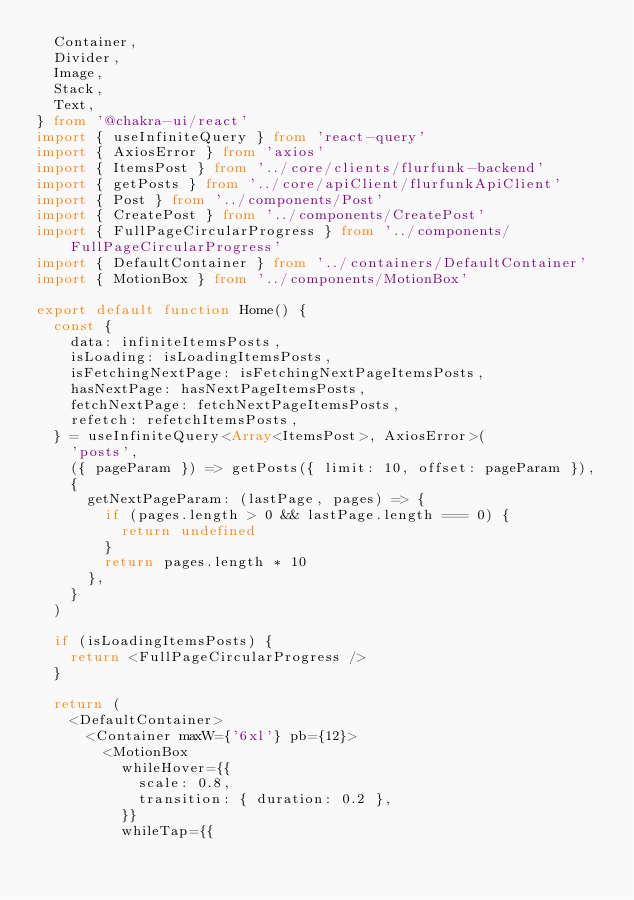Convert code to text. <code><loc_0><loc_0><loc_500><loc_500><_TypeScript_>  Container,
  Divider,
  Image,
  Stack,
  Text,
} from '@chakra-ui/react'
import { useInfiniteQuery } from 'react-query'
import { AxiosError } from 'axios'
import { ItemsPost } from '../core/clients/flurfunk-backend'
import { getPosts } from '../core/apiClient/flurfunkApiClient'
import { Post } from '../components/Post'
import { CreatePost } from '../components/CreatePost'
import { FullPageCircularProgress } from '../components/FullPageCircularProgress'
import { DefaultContainer } from '../containers/DefaultContainer'
import { MotionBox } from '../components/MotionBox'

export default function Home() {
  const {
    data: infiniteItemsPosts,
    isLoading: isLoadingItemsPosts,
    isFetchingNextPage: isFetchingNextPageItemsPosts,
    hasNextPage: hasNextPageItemsPosts,
    fetchNextPage: fetchNextPageItemsPosts,
    refetch: refetchItemsPosts,
  } = useInfiniteQuery<Array<ItemsPost>, AxiosError>(
    'posts',
    ({ pageParam }) => getPosts({ limit: 10, offset: pageParam }),
    {
      getNextPageParam: (lastPage, pages) => {
        if (pages.length > 0 && lastPage.length === 0) {
          return undefined
        }
        return pages.length * 10
      },
    }
  )

  if (isLoadingItemsPosts) {
    return <FullPageCircularProgress />
  }

  return (
    <DefaultContainer>
      <Container maxW={'6xl'} pb={12}>
        <MotionBox
          whileHover={{
            scale: 0.8,
            transition: { duration: 0.2 },
          }}
          whileTap={{</code> 